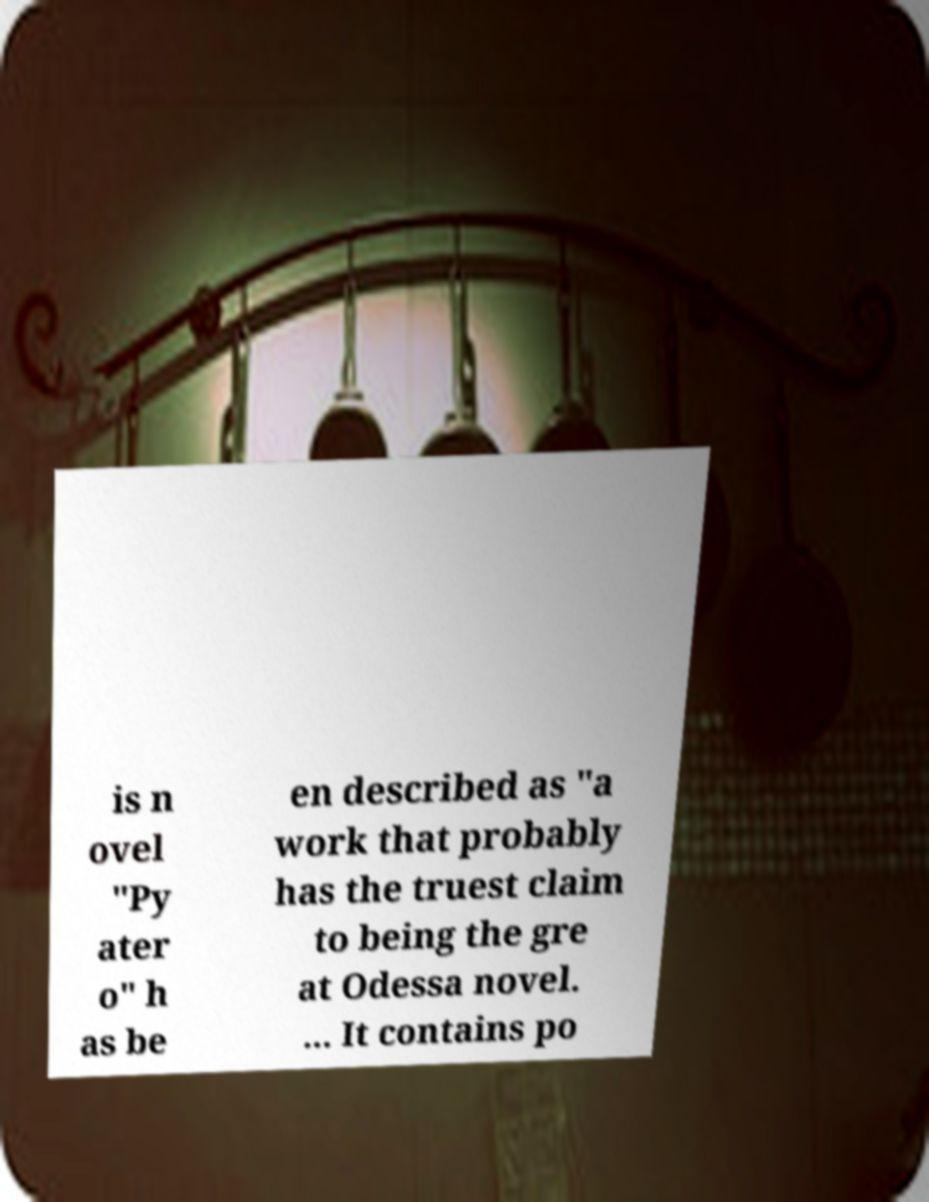Please identify and transcribe the text found in this image. is n ovel "Py ater o" h as be en described as "a work that probably has the truest claim to being the gre at Odessa novel. ... It contains po 